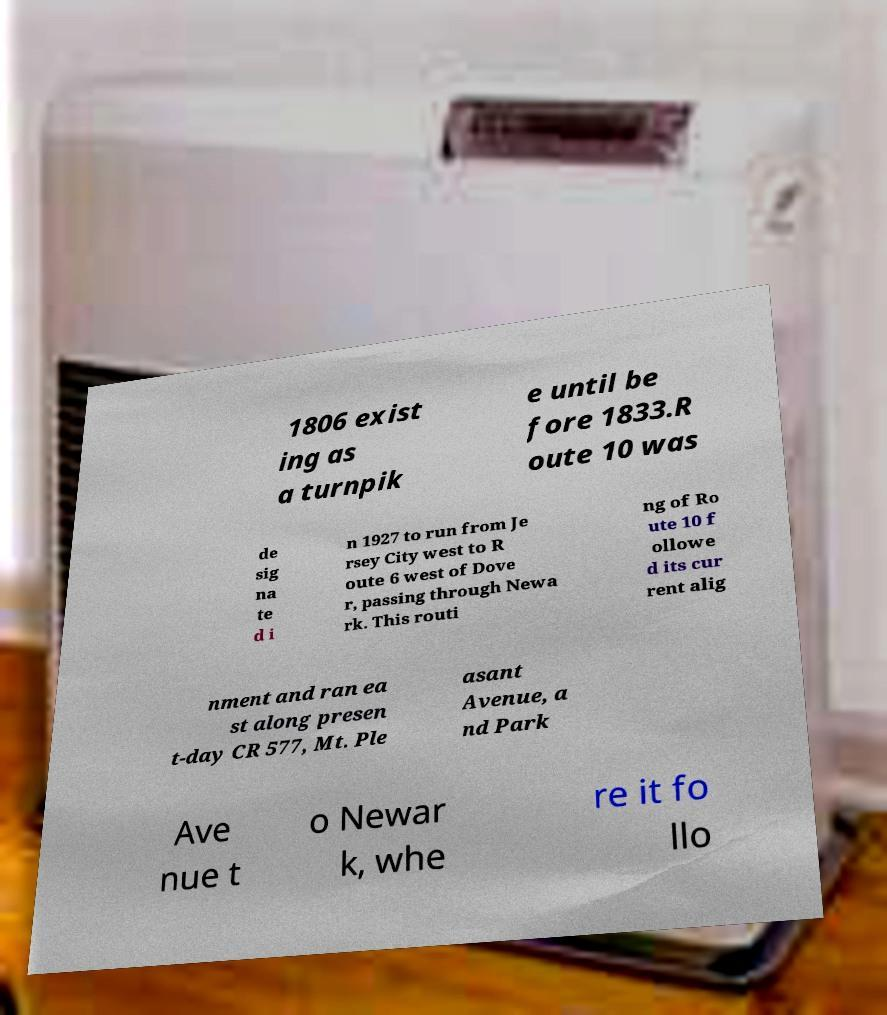Could you extract and type out the text from this image? 1806 exist ing as a turnpik e until be fore 1833.R oute 10 was de sig na te d i n 1927 to run from Je rsey City west to R oute 6 west of Dove r, passing through Newa rk. This routi ng of Ro ute 10 f ollowe d its cur rent alig nment and ran ea st along presen t-day CR 577, Mt. Ple asant Avenue, a nd Park Ave nue t o Newar k, whe re it fo llo 